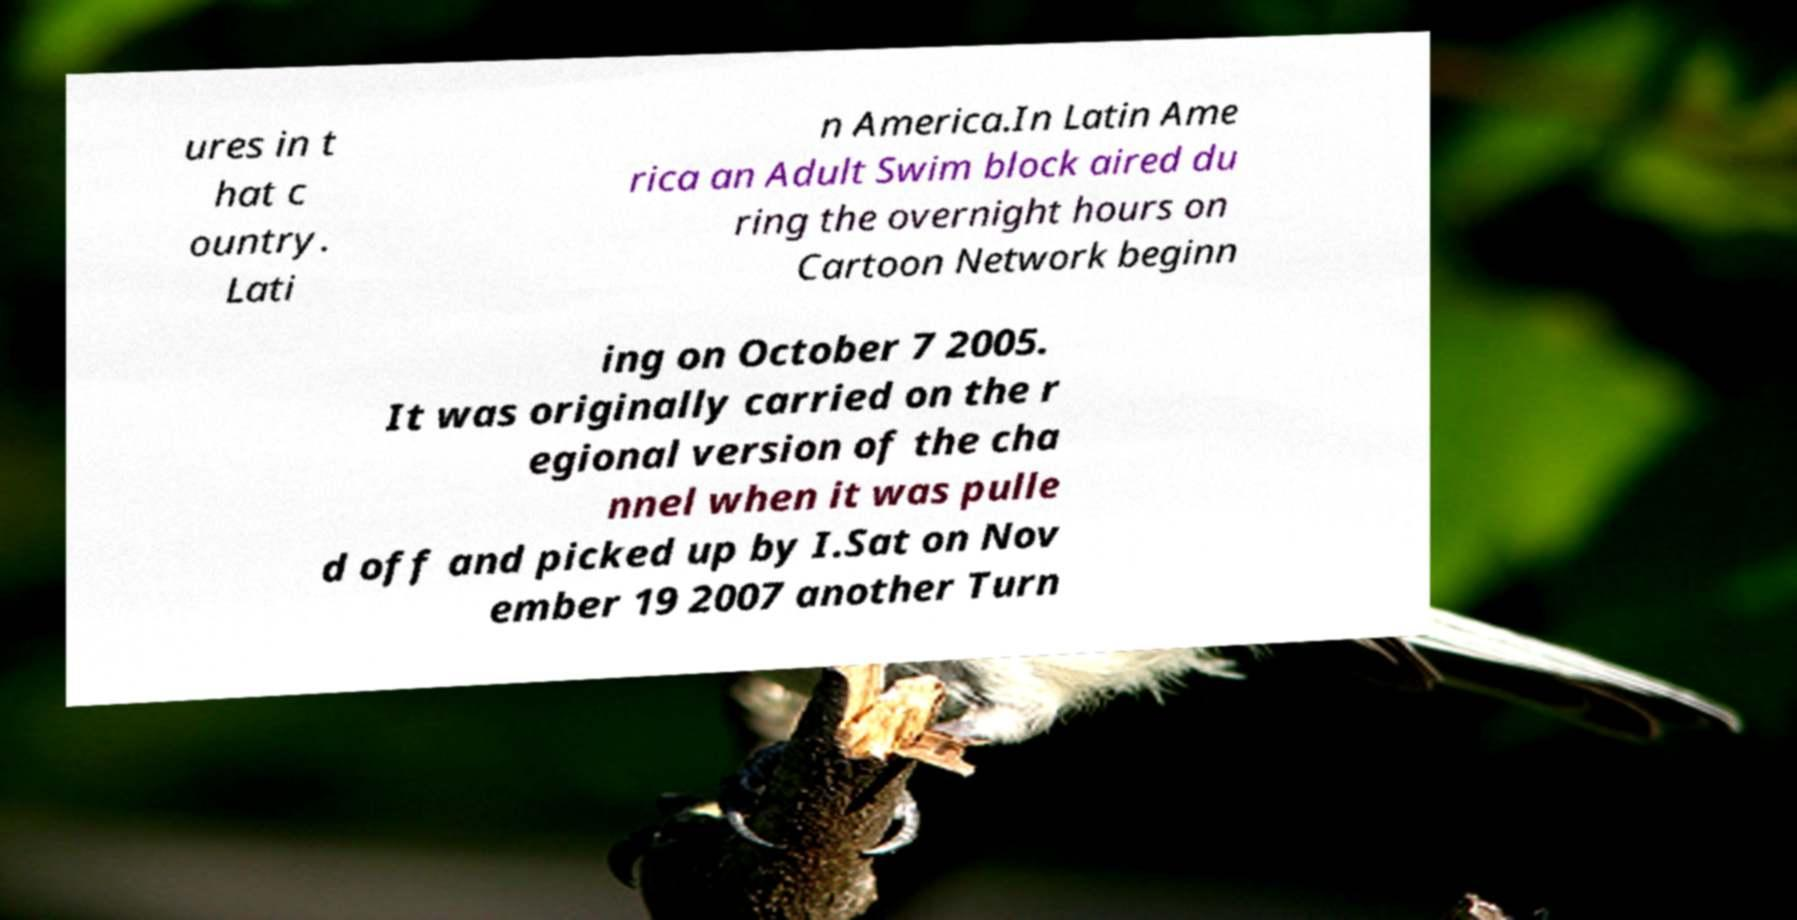Could you extract and type out the text from this image? ures in t hat c ountry. Lati n America.In Latin Ame rica an Adult Swim block aired du ring the overnight hours on Cartoon Network beginn ing on October 7 2005. It was originally carried on the r egional version of the cha nnel when it was pulle d off and picked up by I.Sat on Nov ember 19 2007 another Turn 